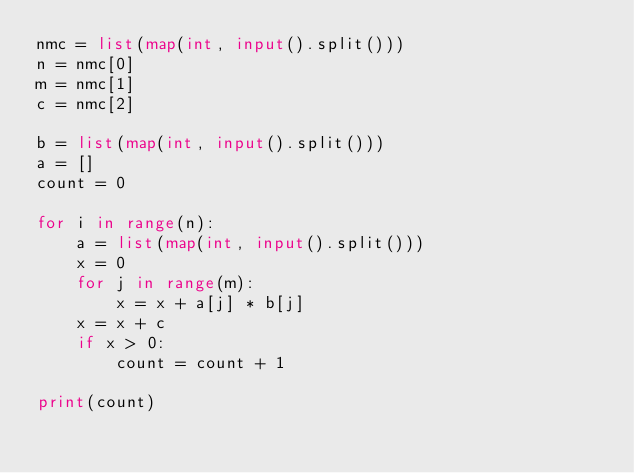Convert code to text. <code><loc_0><loc_0><loc_500><loc_500><_Python_>nmc = list(map(int, input().split()))
n = nmc[0]
m = nmc[1]
c = nmc[2]

b = list(map(int, input().split()))
a = []
count = 0

for i in range(n):
    a = list(map(int, input().split()))
    x = 0
    for j in range(m):
        x = x + a[j] * b[j]
    x = x + c
    if x > 0:
        count = count + 1

print(count)
</code> 